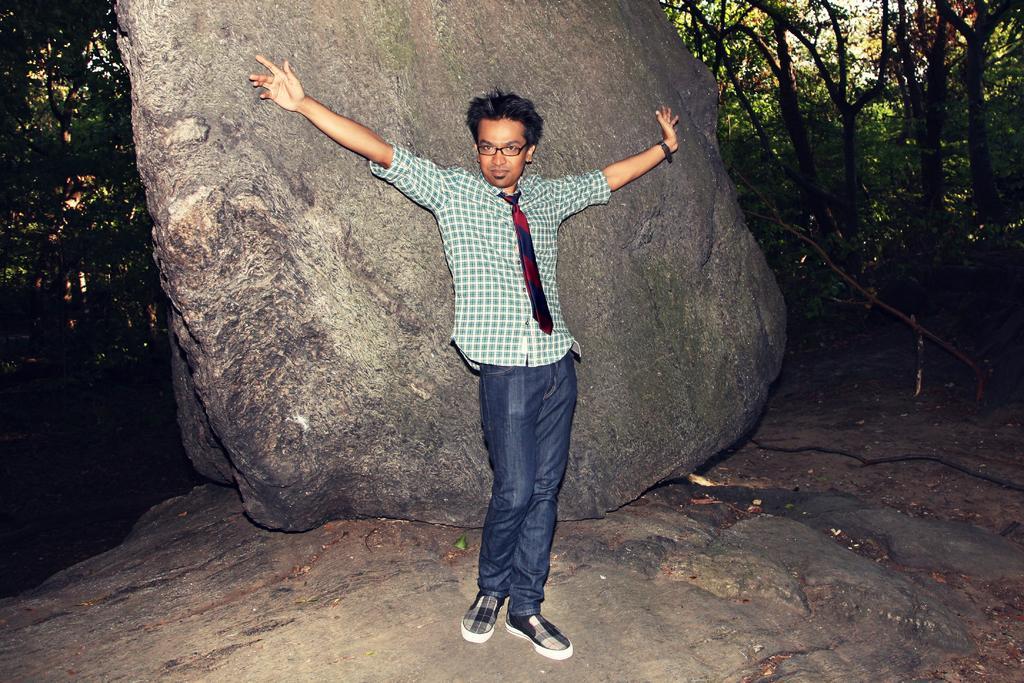In one or two sentences, can you explain what this image depicts? In the image there is a man standing on the rock and he kept spectacle and there is a watch to his hand. Behind him there is a rock. And in the background there are trees. 